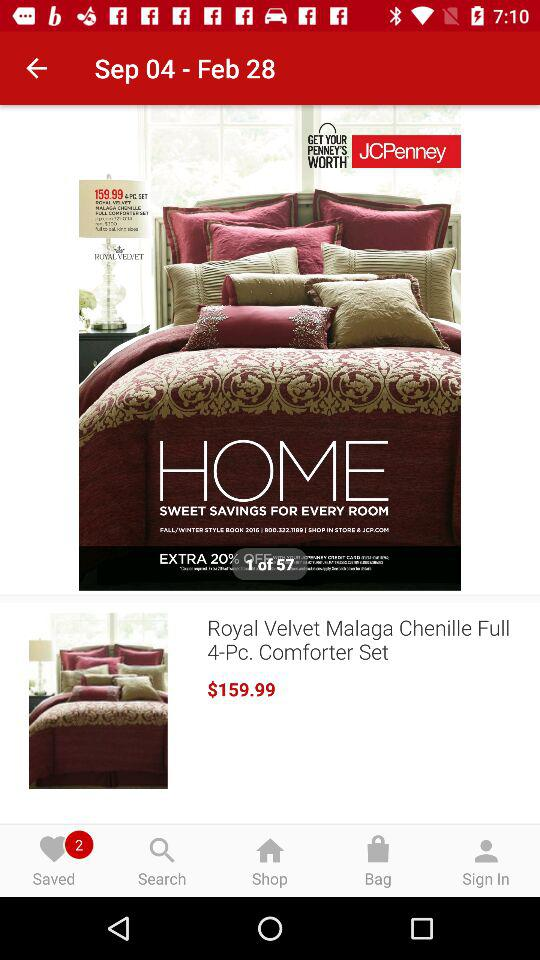How much is the Royal Velvet Malaga Chenille Full 4-Pc. Comforter Set?
Answer the question using a single word or phrase. $159.99 